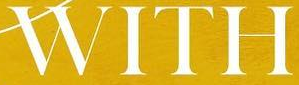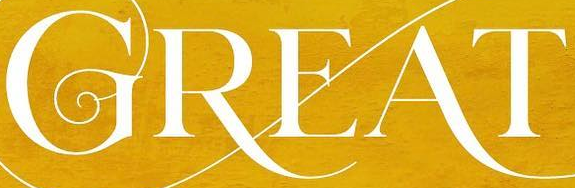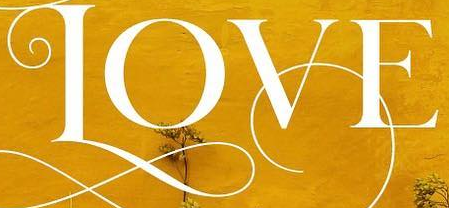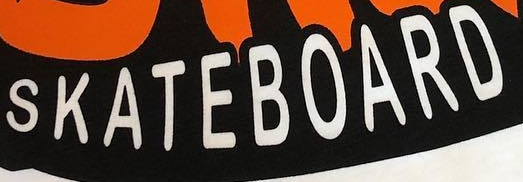Identify the words shown in these images in order, separated by a semicolon. WITH; GREAT; LOVE; SKATEBOARD 